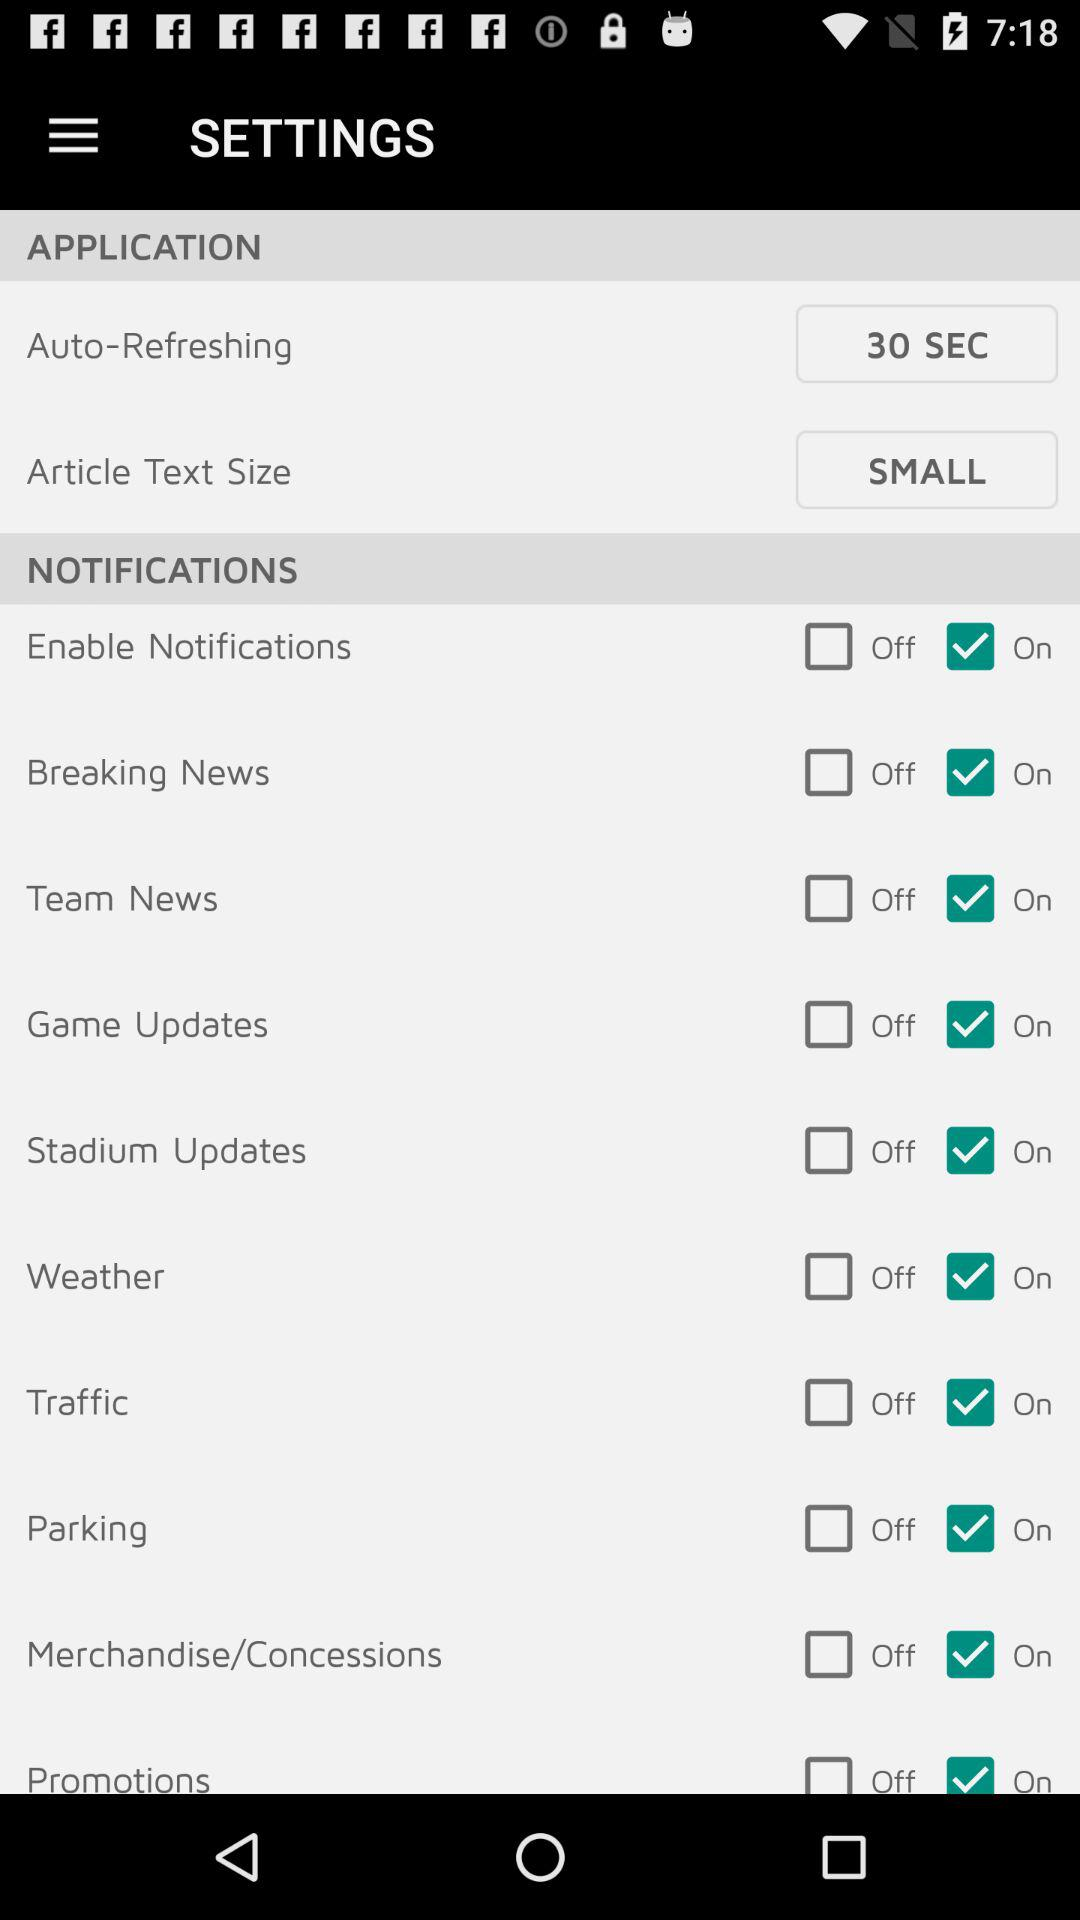What is the status of "Enable Notifications"? "Enable Notifications" is turned on. 